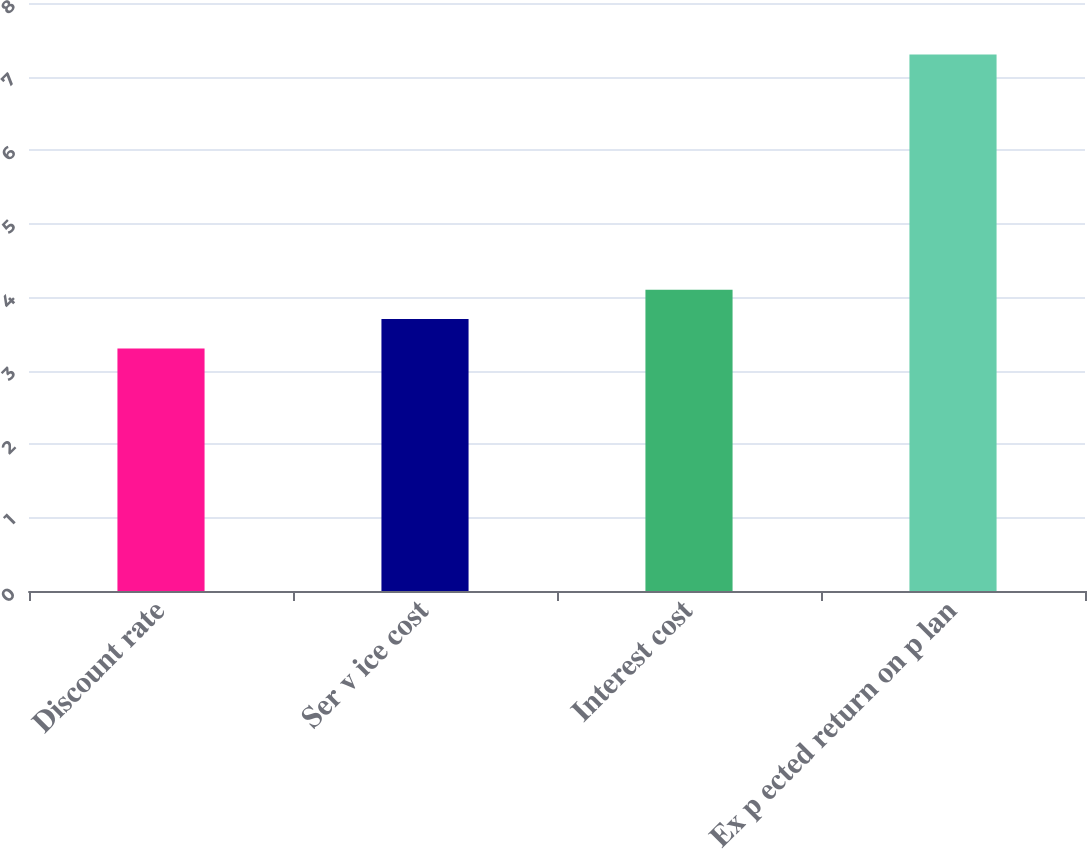Convert chart. <chart><loc_0><loc_0><loc_500><loc_500><bar_chart><fcel>Discount rate<fcel>Ser v ice cost<fcel>Interest cost<fcel>Ex p ected return on p lan<nl><fcel>3.3<fcel>3.7<fcel>4.1<fcel>7.3<nl></chart> 